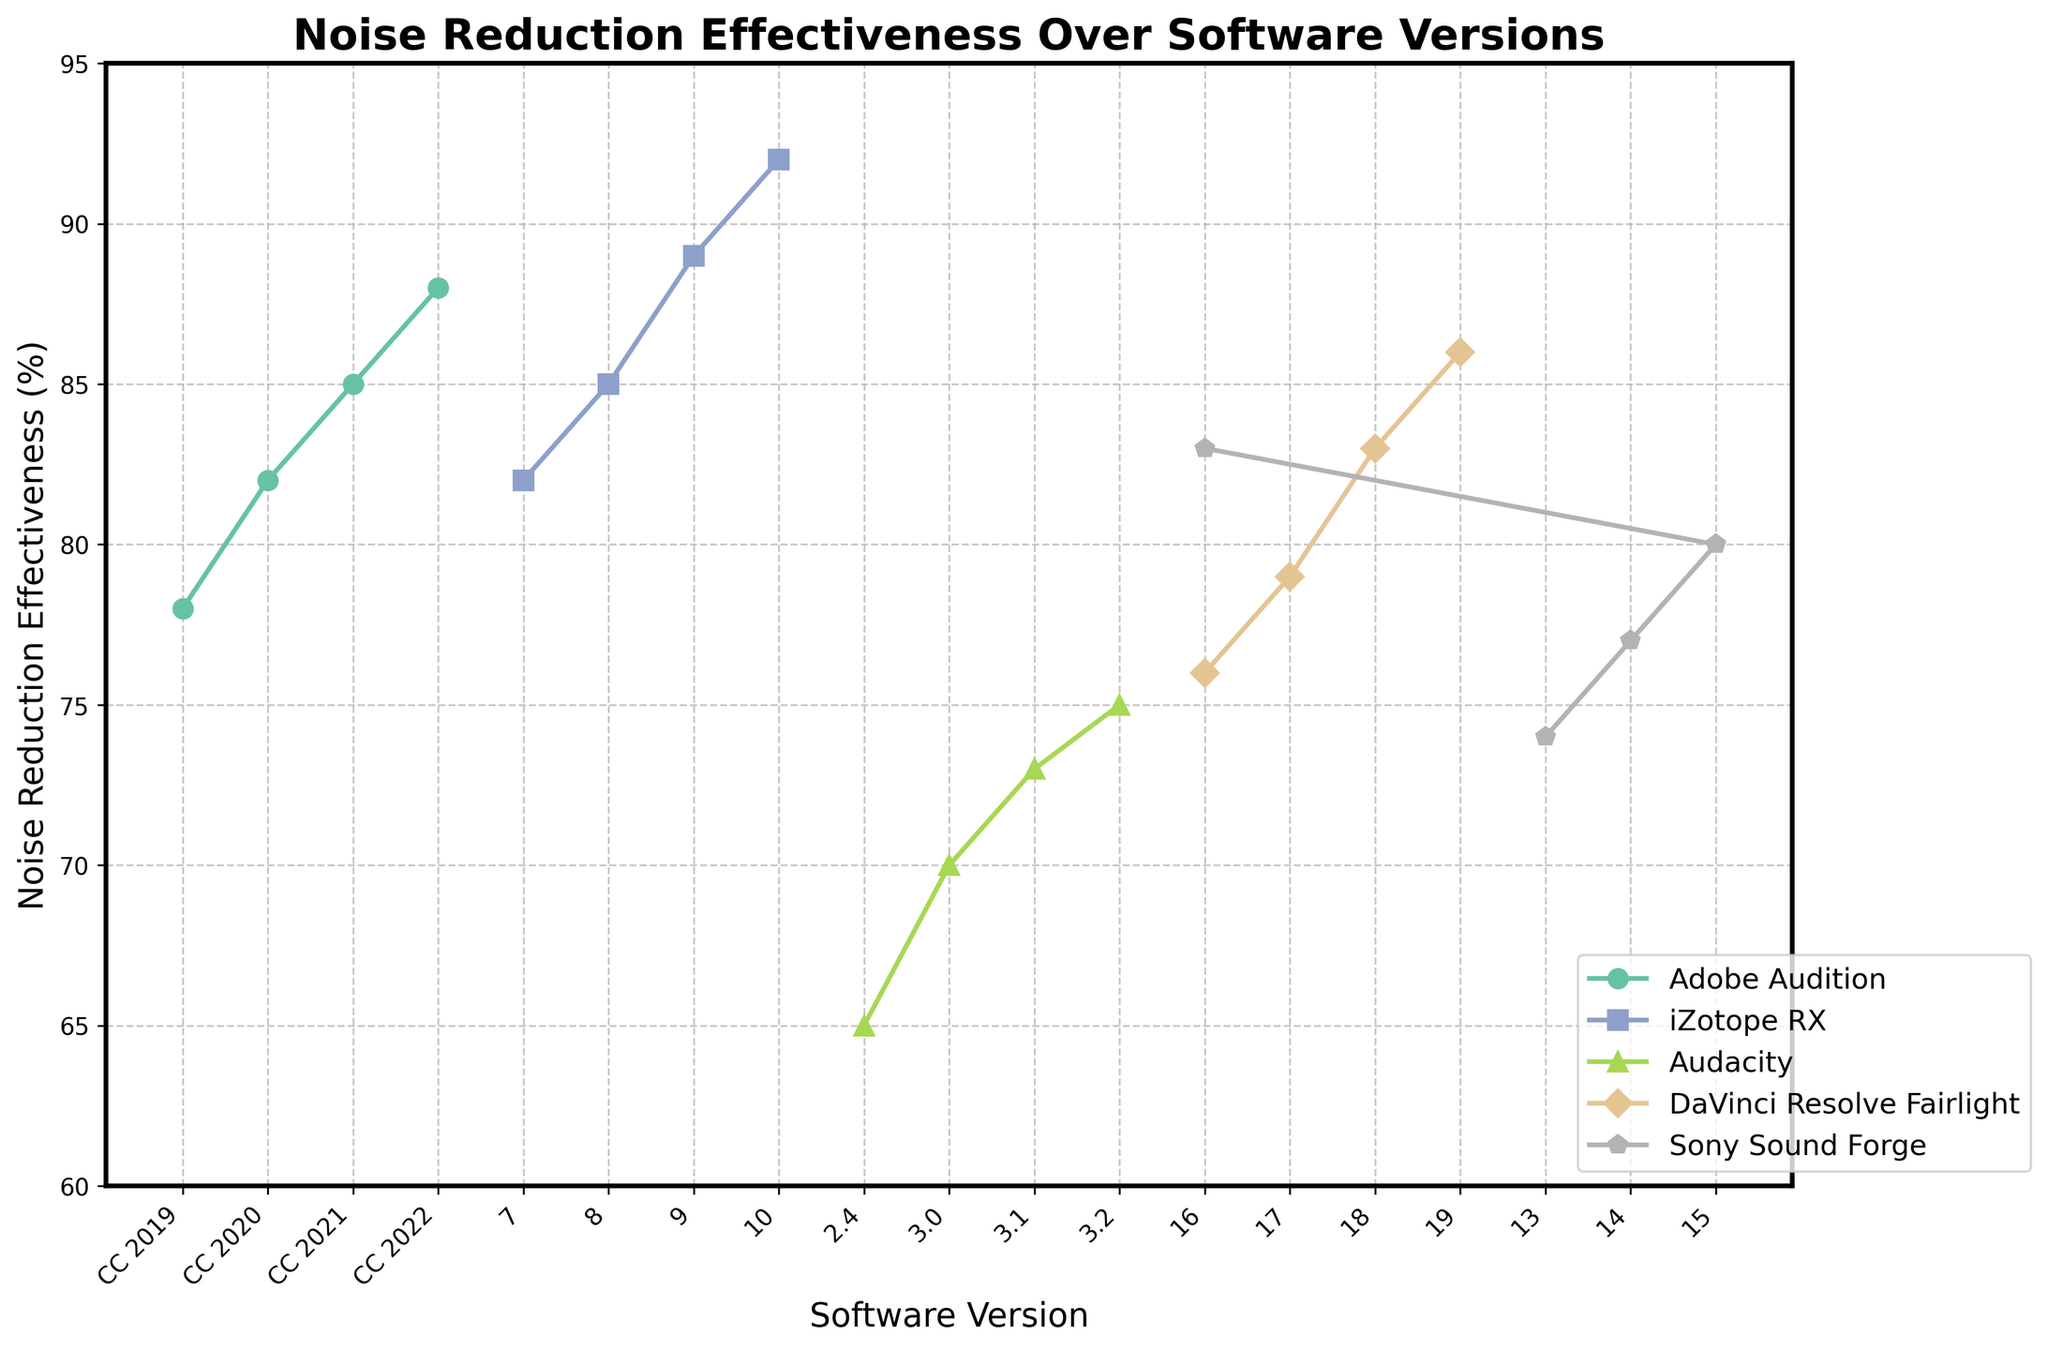How much has the noise reduction effectiveness improved from the first to the latest version of Adobe Audition displayed in the chart? Adobe Audition shows an improvement from 78% in CC 2019 to 88% in CC 2022. The difference is 88% - 78% = 10%.
Answer: 10% Which software shows the highest noise reduction effectiveness in its latest version? Looking at the chart, iZotope RX 10 has the highest noise reduction effectiveness at 92%.
Answer: iZotope RX Between which versions of DaVinci Resolve Fairlight is the increase in noise reduction effectiveness the greatest? Comparing the improvements: 76% to 79% (3 units), 79% to 83% (4 units), 83% to 86% (3 units), the largest increase is from 17 to 18 with a 4 units increment.
Answer: 17 to 18 Compare the noise reduction effectiveness of the initial version of Audacity to the final version of iZotope RX. Which is higher, and by how much? Audacity 2.4 has 65%, and iZotope RX 10 has 92%. The difference is 92% - 65% = 27%.
Answer: iZotope RX by 27% What is the average noise reduction effectiveness across all versions of Sony Sound Forge shown in the chart? The versions have effectiveness values 74%, 77%, 80%, and 83%. The average is (74 + 77 + 80 + 83) / 4 = 78.5%.
Answer: 78.5% Which software has the steepest increase in noise reduction effectiveness from one version to the next? iZotope RX shows the steepest increase from version 9 (89%) to version 10 (92%), with a 3% increase.
Answer: iZotope RX Which software version had the lowest noise reduction effectiveness, and what was its value? The lowest effectiveness in the chart is Audacity 2.4, which is at 65%.
Answer: Audacity 2.4 How does the noise reduction effectiveness of DaVinci Resolve Fairlight 19 compare to Adobe Audition CC 2022? DaVinci Resolve Fairlight 19 is at 86%, while Adobe Audition CC 2022 is at 88%. Adobe Audition CC 2022 is 2% higher.
Answer: Adobe Audition CC 2022 by 2% What is the overall trend seen in the noise reduction effectiveness across versions for all software? Across all software, there is a general upward trend in noise reduction effectiveness with each subsequent version.
Answer: Upward trend 